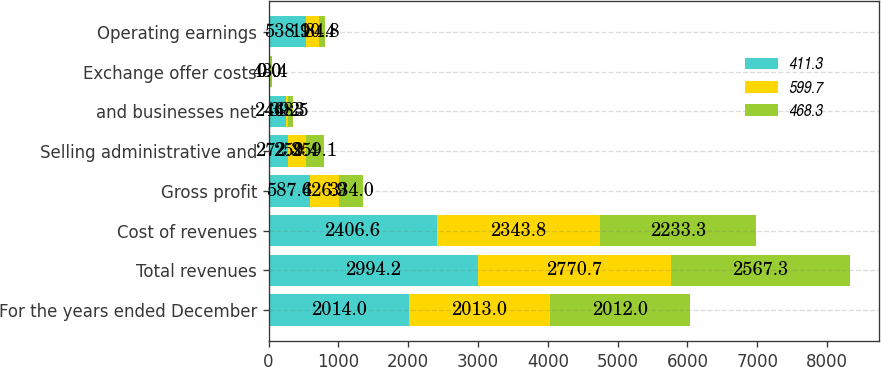<chart> <loc_0><loc_0><loc_500><loc_500><stacked_bar_chart><ecel><fcel>For the years ended December<fcel>Total revenues<fcel>Cost of revenues<fcel>Gross profit<fcel>Selling administrative and<fcel>and businesses net<fcel>Exchange offer costs<fcel>Operating earnings<nl><fcel>411.3<fcel>2014<fcel>2994.2<fcel>2406.6<fcel>587.6<fcel>272.3<fcel>244.2<fcel>0<fcel>538.1<nl><fcel>599.7<fcel>2013<fcel>2770.7<fcel>2343.8<fcel>426.9<fcel>259.4<fcel>39.3<fcel>0<fcel>190.4<nl><fcel>468.3<fcel>2012<fcel>2567.3<fcel>2233.3<fcel>334<fcel>259.1<fcel>68.5<fcel>43.4<fcel>84.8<nl></chart> 